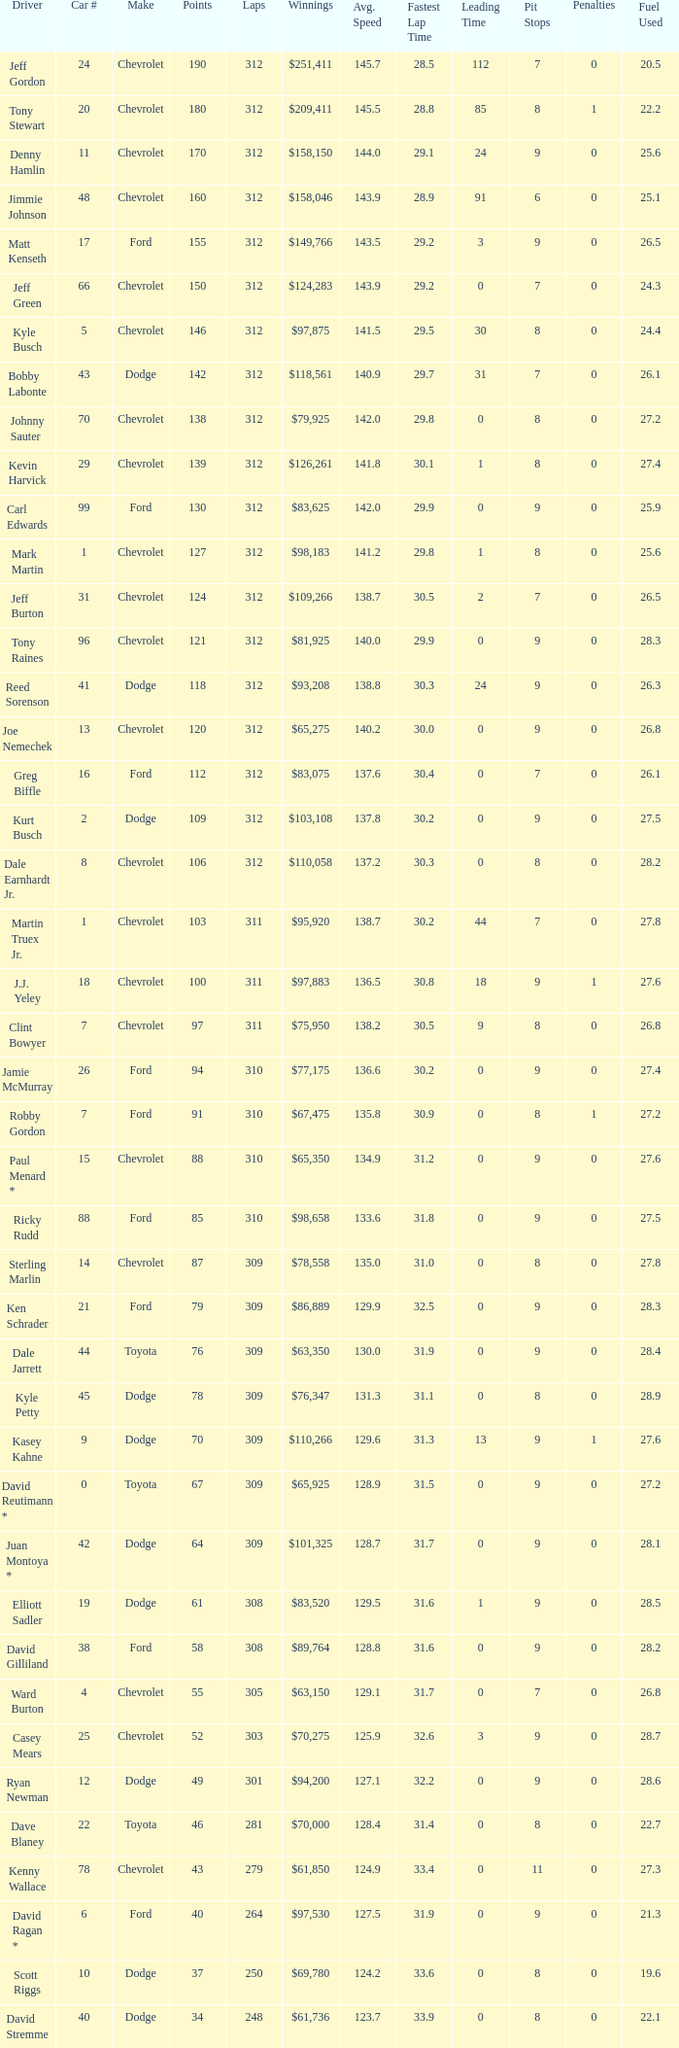What is the lowest number of laps for kyle petty with under 118 points? 309.0. 